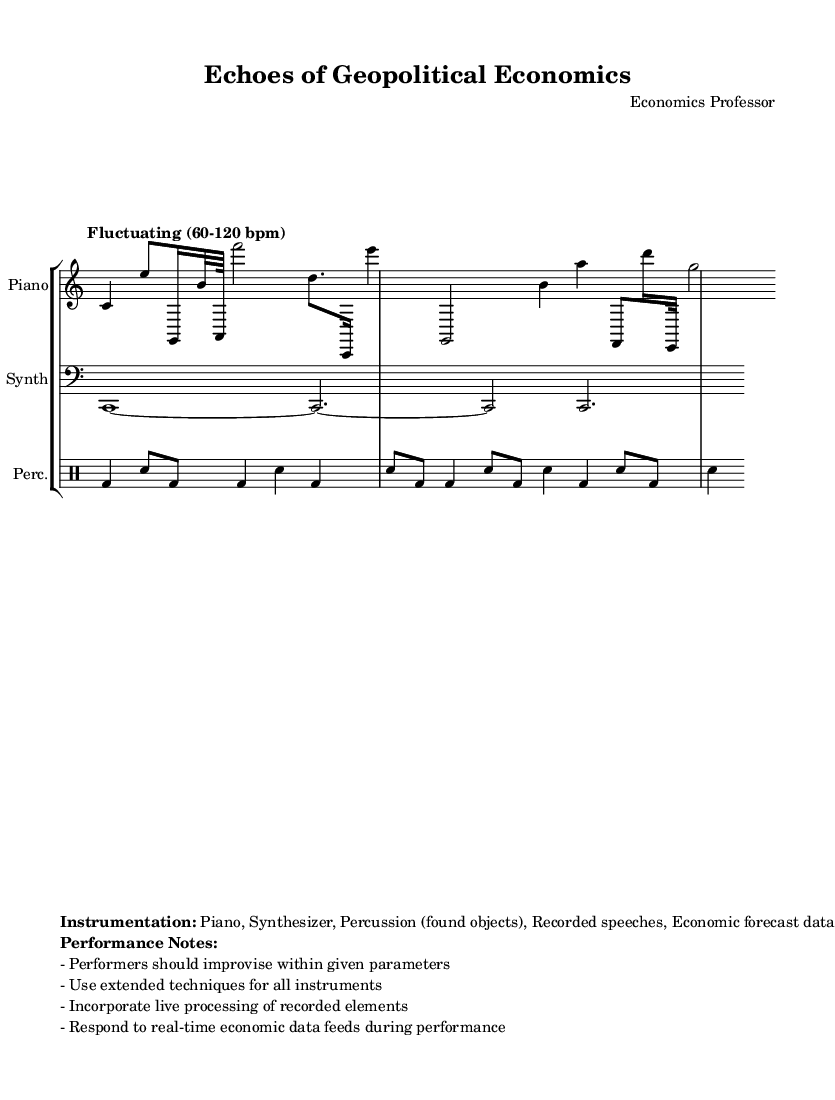What is the time signature of the first section? The first section has a time signature of 4/4, as indicated at the beginning of the staff for the piano.
Answer: 4/4 What instruments are included in this score? The score includes Piano, Synthesizer, and Percussion (found objects), as listed in the instructions under instrumentation.
Answer: Piano, Synthesizer, Percussion How many measures are in the piano part? By counting the measures in the piano part, there are a total of three measures, indicated by the vertical lines on the staff.
Answer: Three What is the tempo marking provided in the sheet music? The tempo marking is described as "Fluctuating (60-120 bpm)", meaning the speed is intended to vary between those beats per minute.
Answer: Fluctuating (60-120 bpm) What unique element is specified in the performance notes for the instrumentation? The performance notes specify that performers should incorporate live processing of recorded elements, which is a distinctive feature in this experimental piece.
Answer: Live processing of recorded elements What type of sound techniques should performers use? Performers are instructed to use extended techniques for all instruments, which suggests non-traditional playing methods.
Answer: Extended techniques How does the piece integrate real-time influences? The piece is designed to respond to real-time economic data feeds during performance, making it interactive and contemporary.
Answer: Real-time economic data feeds 